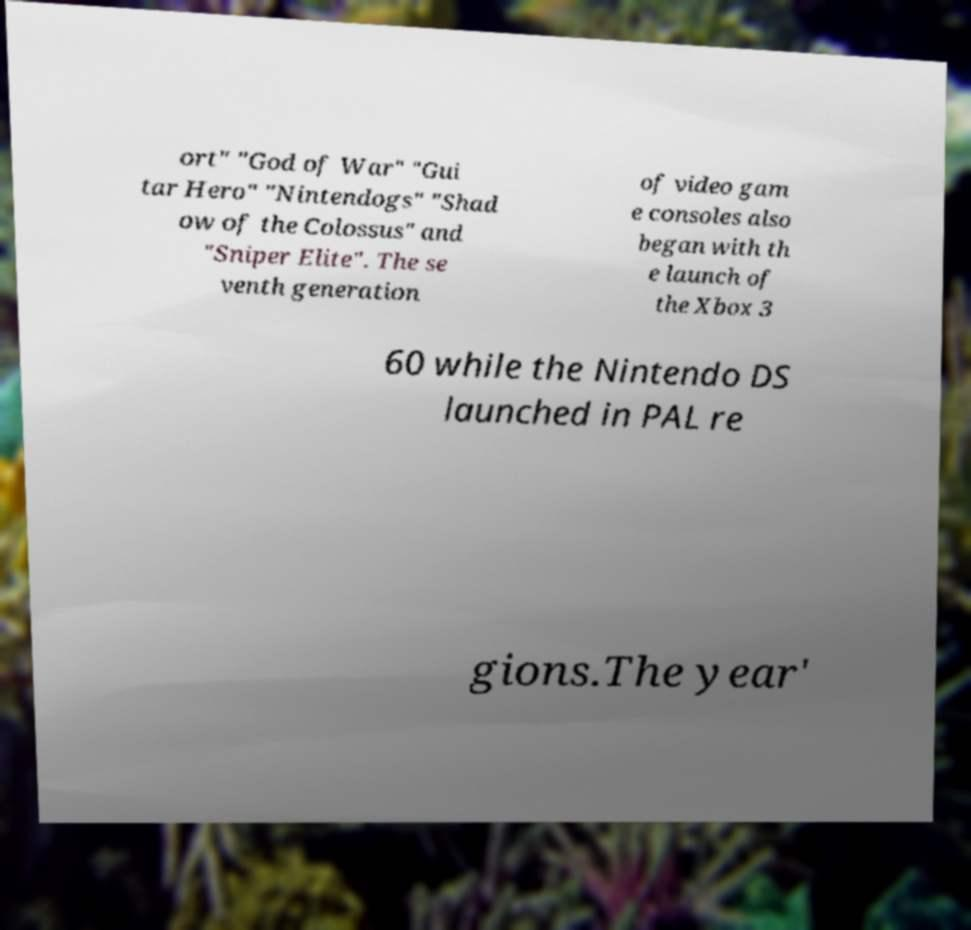For documentation purposes, I need the text within this image transcribed. Could you provide that? ort" "God of War" "Gui tar Hero" "Nintendogs" "Shad ow of the Colossus" and "Sniper Elite". The se venth generation of video gam e consoles also began with th e launch of the Xbox 3 60 while the Nintendo DS launched in PAL re gions.The year' 